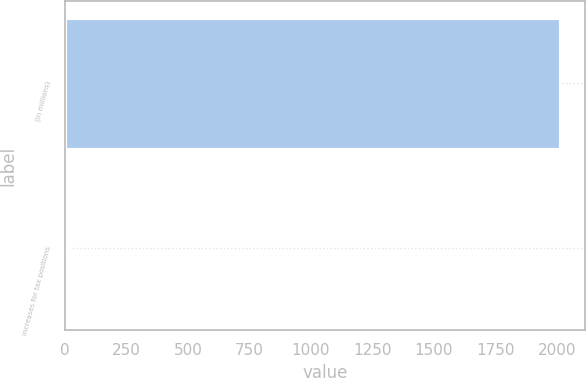Convert chart to OTSL. <chart><loc_0><loc_0><loc_500><loc_500><bar_chart><fcel>(In millions)<fcel>Increases for tax positions<nl><fcel>2014<fcel>10<nl></chart> 